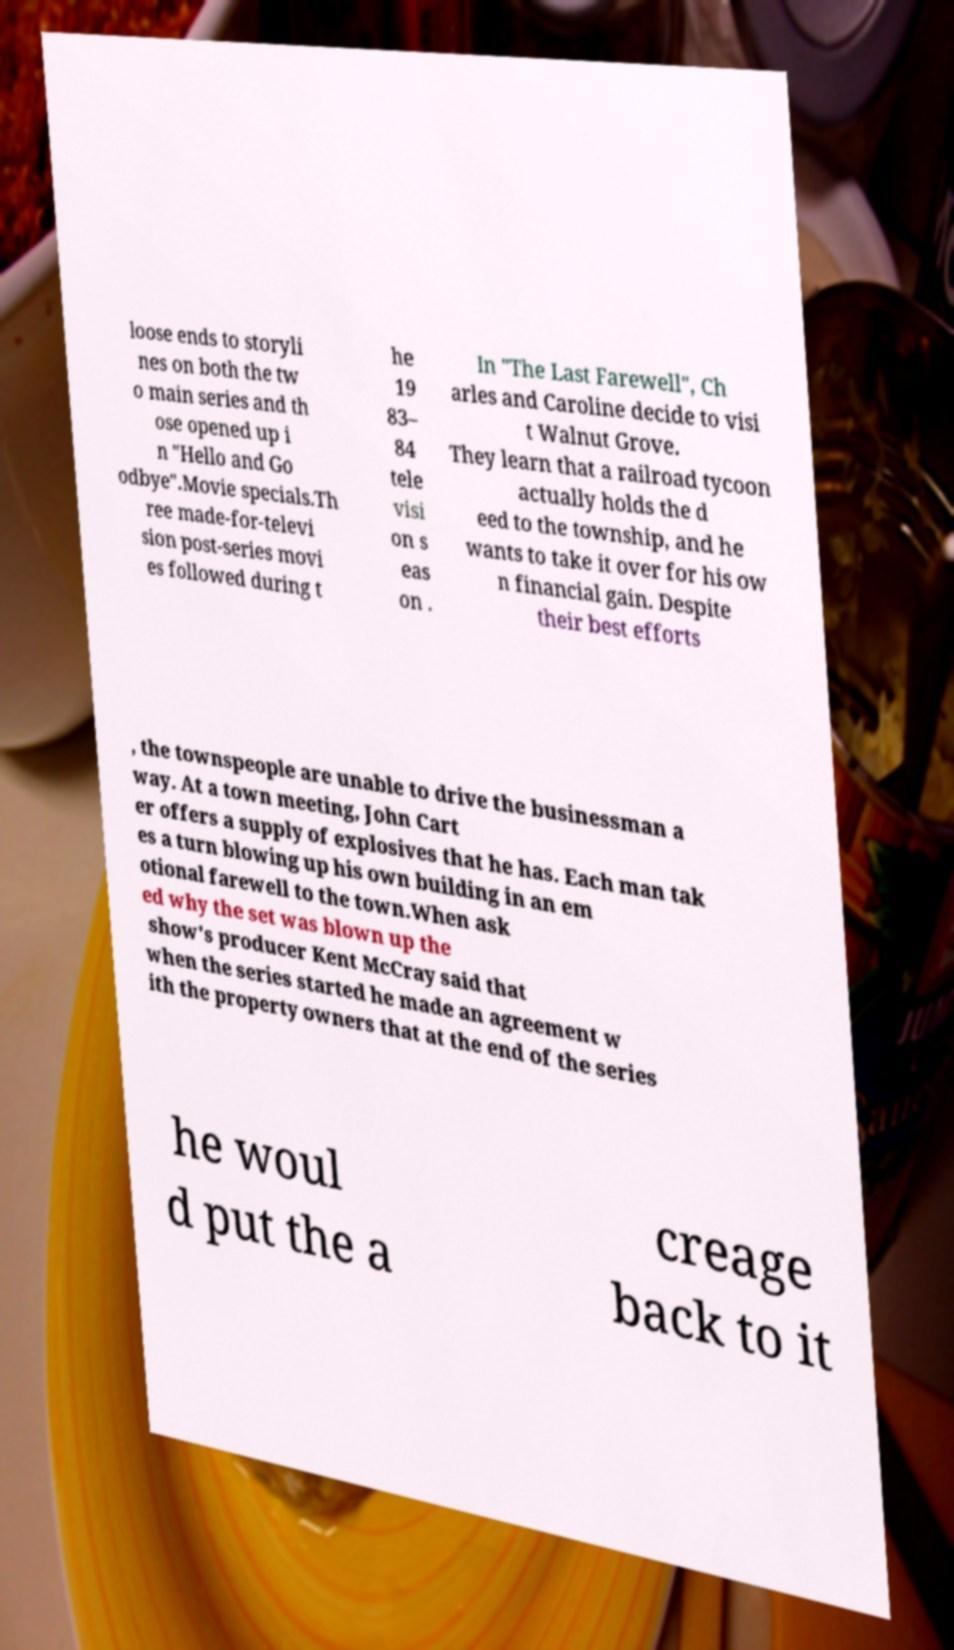Can you read and provide the text displayed in the image?This photo seems to have some interesting text. Can you extract and type it out for me? loose ends to storyli nes on both the tw o main series and th ose opened up i n "Hello and Go odbye".Movie specials.Th ree made-for-televi sion post-series movi es followed during t he 19 83– 84 tele visi on s eas on . In "The Last Farewell", Ch arles and Caroline decide to visi t Walnut Grove. They learn that a railroad tycoon actually holds the d eed to the township, and he wants to take it over for his ow n financial gain. Despite their best efforts , the townspeople are unable to drive the businessman a way. At a town meeting, John Cart er offers a supply of explosives that he has. Each man tak es a turn blowing up his own building in an em otional farewell to the town.When ask ed why the set was blown up the show's producer Kent McCray said that when the series started he made an agreement w ith the property owners that at the end of the series he woul d put the a creage back to it 